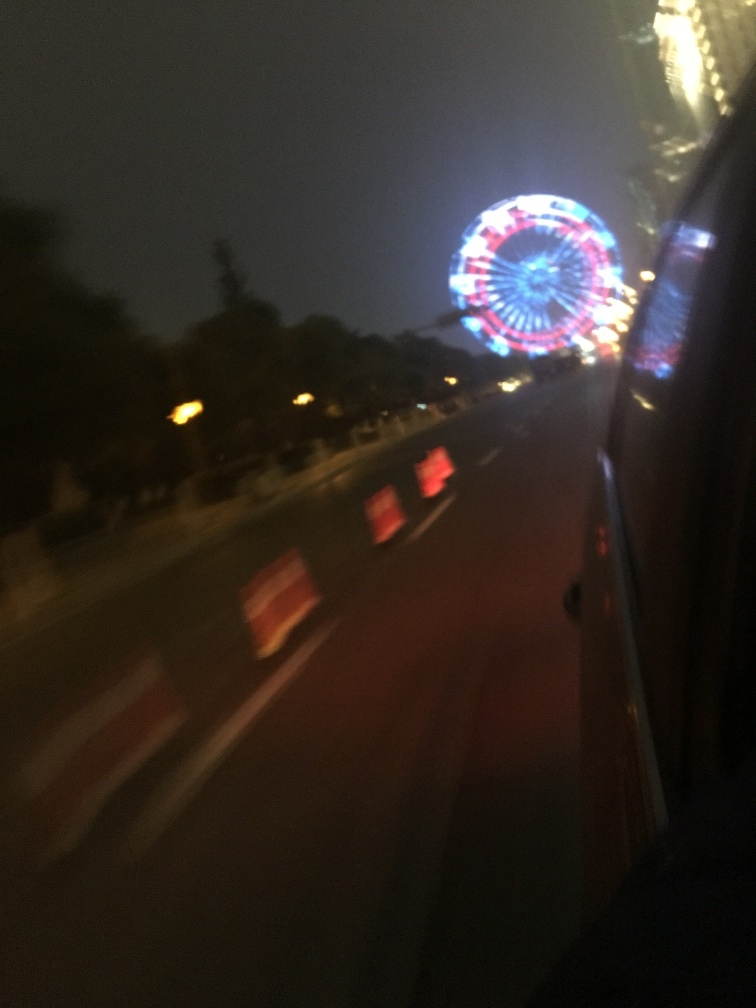Are there any exposure issues in the image? The image shows some motion blur, particularly noticeable in the brightly lit Ferris wheel, which appears dynamic and somewhat overexposed compared to the darker surrounding areas. This blur and exposure contrast create a vivid, though slightly unfocused, nighttime scene. Adjusting the shutter speed or stabilizing the camera could potentially improve clarity and exposure balance. 